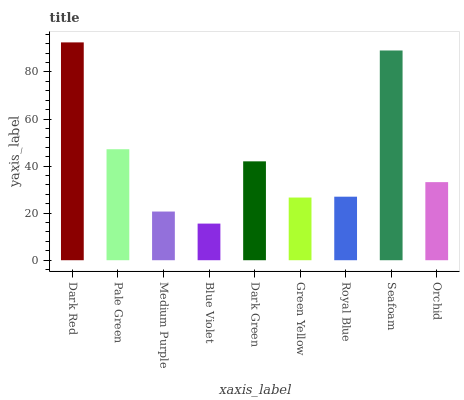Is Blue Violet the minimum?
Answer yes or no. Yes. Is Dark Red the maximum?
Answer yes or no. Yes. Is Pale Green the minimum?
Answer yes or no. No. Is Pale Green the maximum?
Answer yes or no. No. Is Dark Red greater than Pale Green?
Answer yes or no. Yes. Is Pale Green less than Dark Red?
Answer yes or no. Yes. Is Pale Green greater than Dark Red?
Answer yes or no. No. Is Dark Red less than Pale Green?
Answer yes or no. No. Is Orchid the high median?
Answer yes or no. Yes. Is Orchid the low median?
Answer yes or no. Yes. Is Seafoam the high median?
Answer yes or no. No. Is Dark Red the low median?
Answer yes or no. No. 